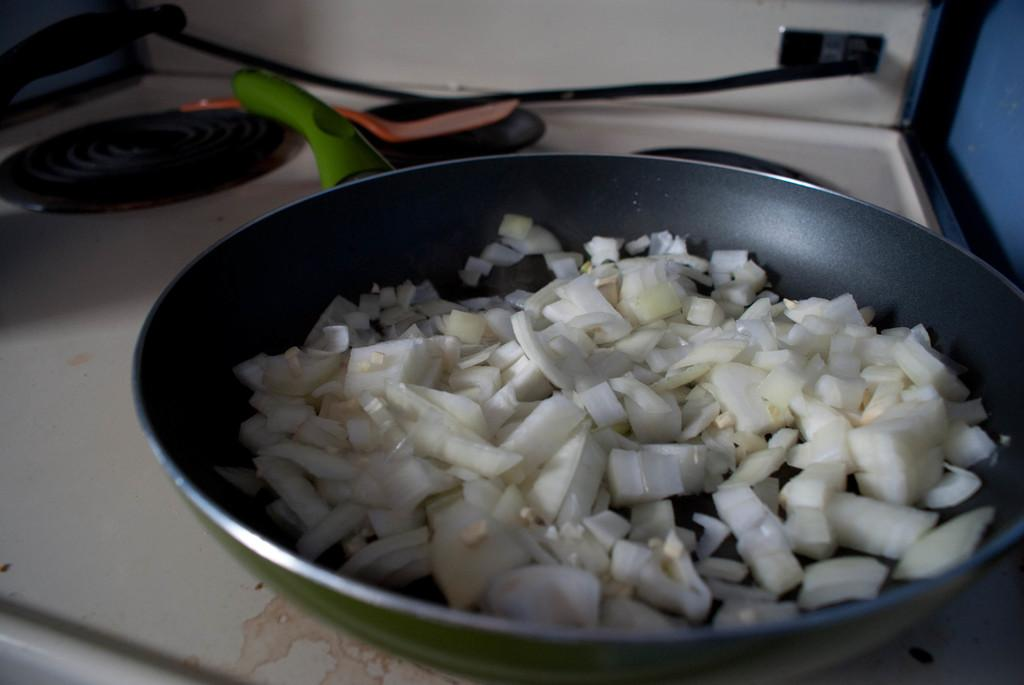What is the main object in the center of the image? There is a table in the center of the image. What items can be seen on the table? On the table, there is a wooden spoon, a pan, and onion slices. Are there any other objects on the table? Yes, there are other objects on the table. What year is depicted in the scene at the harbor in the image? There is no scene at a harbor in the image, and therefore no year can be determined. 